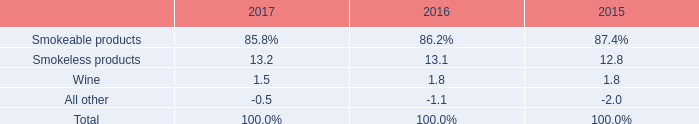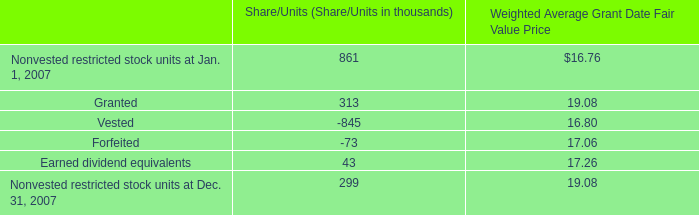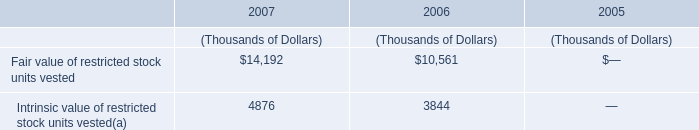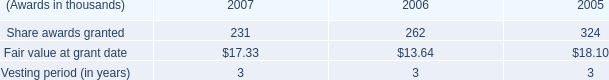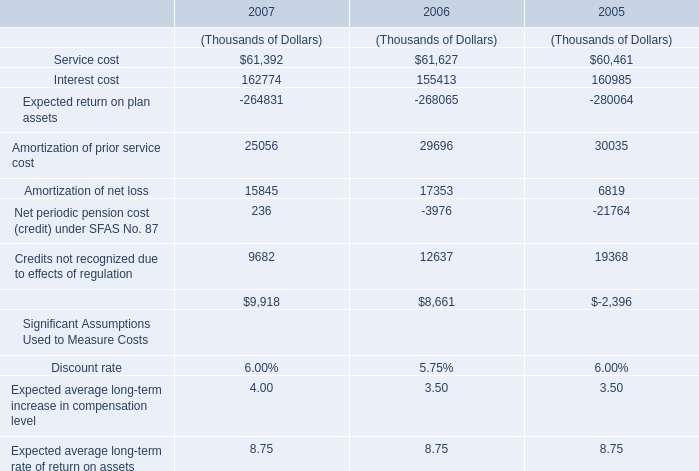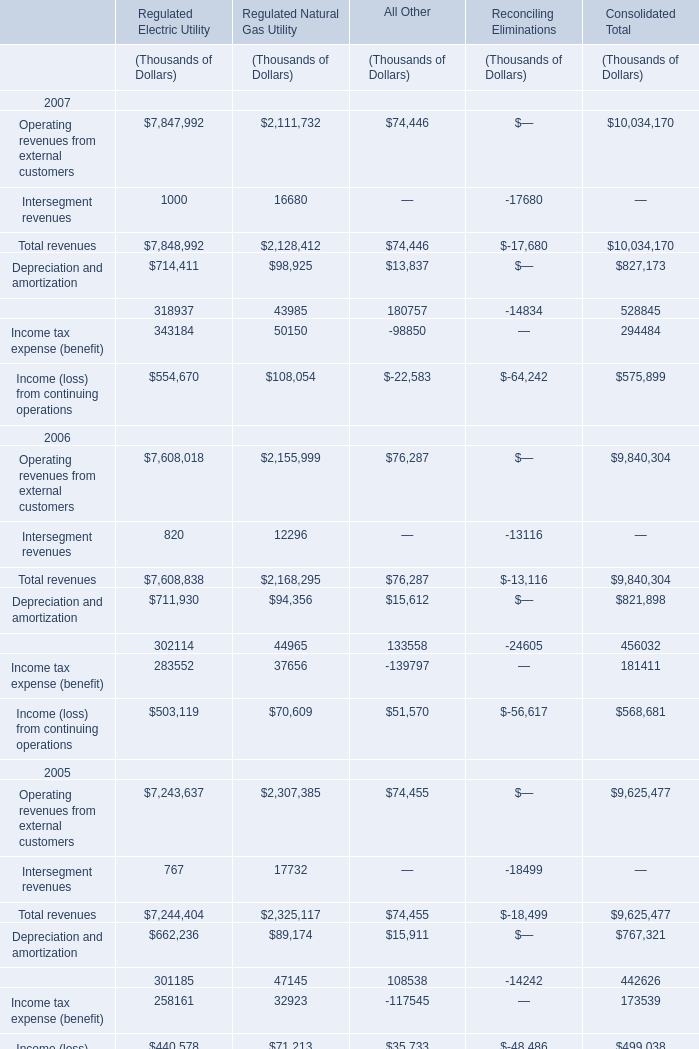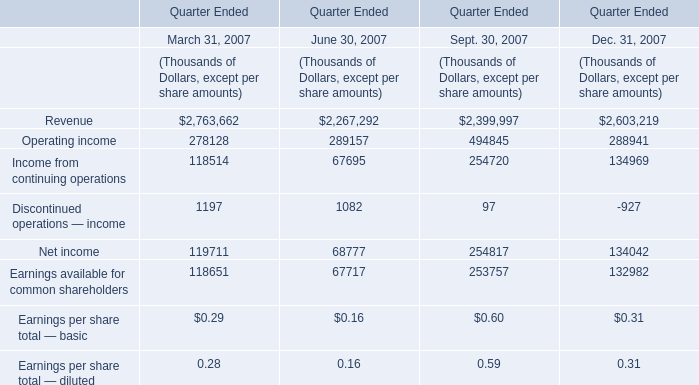what is the percentage change in the weight of smokeless products in operating income from 2015 to 2016? 
Computations: ((13.1 - 12.8) / 12.8)
Answer: 0.02344. 